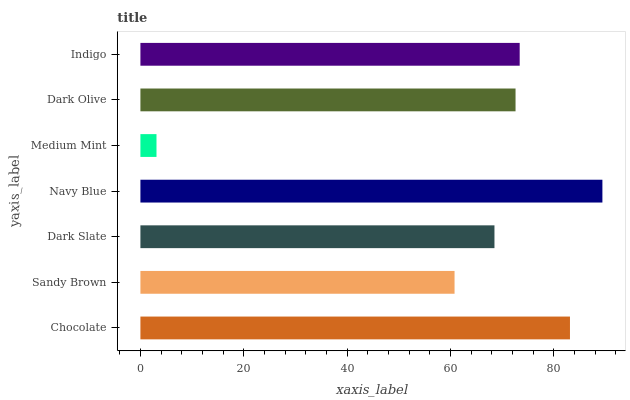Is Medium Mint the minimum?
Answer yes or no. Yes. Is Navy Blue the maximum?
Answer yes or no. Yes. Is Sandy Brown the minimum?
Answer yes or no. No. Is Sandy Brown the maximum?
Answer yes or no. No. Is Chocolate greater than Sandy Brown?
Answer yes or no. Yes. Is Sandy Brown less than Chocolate?
Answer yes or no. Yes. Is Sandy Brown greater than Chocolate?
Answer yes or no. No. Is Chocolate less than Sandy Brown?
Answer yes or no. No. Is Dark Olive the high median?
Answer yes or no. Yes. Is Dark Olive the low median?
Answer yes or no. Yes. Is Sandy Brown the high median?
Answer yes or no. No. Is Chocolate the low median?
Answer yes or no. No. 